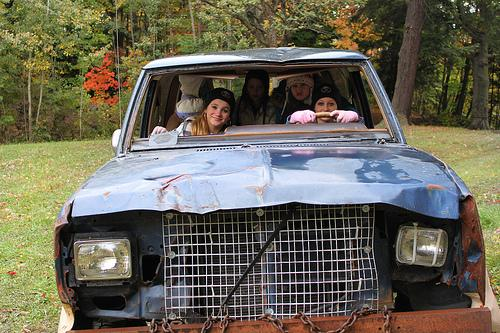What is the woman in the car wearing on her head? She's wearing a black cap. Mention a few adjectives that describe the car in the image. old, blue, beat-up, and with a rusted bumper Can you describe the interaction between the people inside the car and their environment? The people are sitting inside the car, with two hands on the steering wheel, surrounded by a green grassy field and trees with red and green leaves. Are there any trees in the background, and if so, what is the color of their leaves? Yes, there are trees with both green and red leaves. What type of car is in the image, and what color is it? It's an old car, and it's blue. What emotions or sentiments are conveyed by the image? The image conveys a sense of nostalgia and age due to the old car and surrounding nature. Enumerate some notable features of the girl's appearance. The girl has brown hair, she's wearing a black hat and an earring. Please describe the condition of the car's headlight and bumper. The headlight is old and square, with zipties on it. The bumper is rusted with chains on it. Can you tell me how many people are inside the car? There are two people sitting in the car. What can you say about the condition of the car's roof?  The roof of the car is dented. 